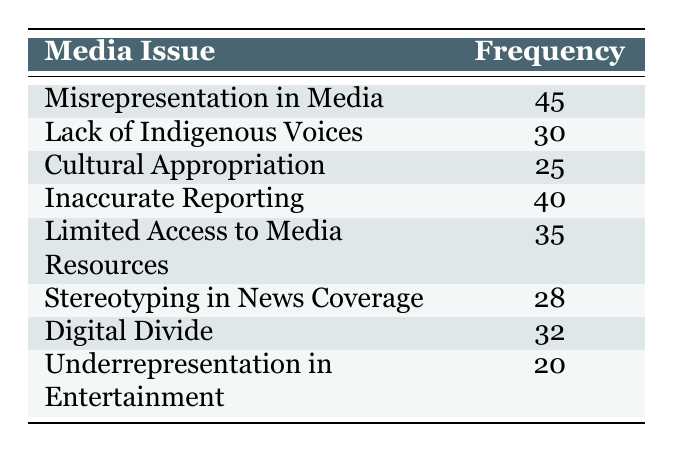What is the frequency of "Misrepresentation in Media"? The table lists "Misrepresentation in Media" with a frequency of 45. Therefore, the answer is directly found in the table.
Answer: 45 What issue has the lowest frequency? Looking through the frequencies, "Underrepresentation in Entertainment" has the lowest value at 20. Comparing all the frequency values confirms this is the lowest.
Answer: Underrepresentation in Entertainment What is the sum of frequencies for "Cultural Appropriation" and "Stereotyping in News Coverage"? The frequencies for these issues are 25 for "Cultural Appropriation" and 28 for "Stereotyping in News Coverage." Adding these frequencies together gives 25 + 28 = 53.
Answer: 53 Is "Digital Divide" reported more frequently than "Lack of Indigenous Voices"? The frequency of "Digital Divide" is 32, while "Lack of Indigenous Voices" has a frequency of 30. Since 32 is greater than 30, the answer is yes.
Answer: Yes What is the average frequency of the media issues listed? To find the average, sum the frequencies: 45 + 30 + 25 + 40 + 35 + 28 + 32 + 20 = 305. There are 8 issues, so the average frequency is 305 divided by 8, which equals 38.125.
Answer: 38.125 How many issues have a frequency greater than 30? The values greater than 30 are: 45, 40, 35, and 32. Counting these, we find there are 4 issues with a frequency above 30.
Answer: 4 What is the frequency difference between "Inaccurate Reporting" and "Cultural Appropriation"? The frequency for "Inaccurate Reporting" is 40 and for "Cultural Appropriation" it is 25. Finding the difference, we subtract: 40 - 25 = 15.
Answer: 15 Is the frequency of "Limited Access to Media Resources" greater than or equal to the frequency of "Misrepresentation in Media"? The frequency for "Limited Access to Media Resources" is 35, and for "Misrepresentation in Media" it is 45. Since 35 is not greater than or equal to 45, the answer is no.
Answer: No 